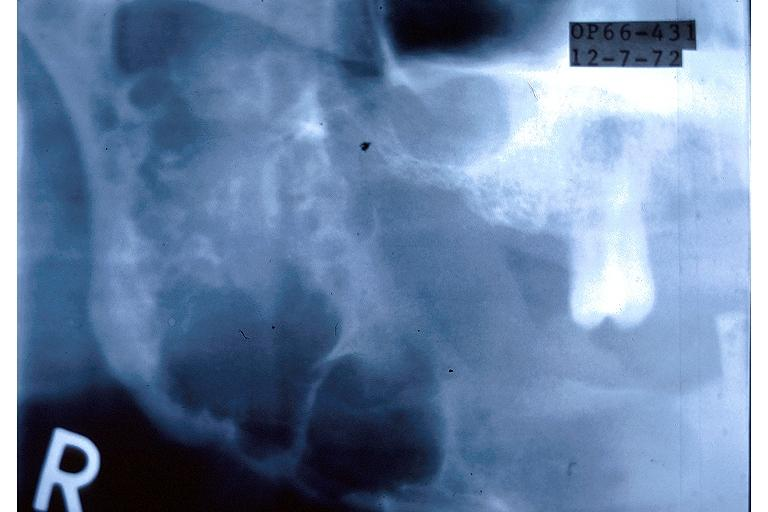s male reproductive present?
Answer the question using a single word or phrase. No 